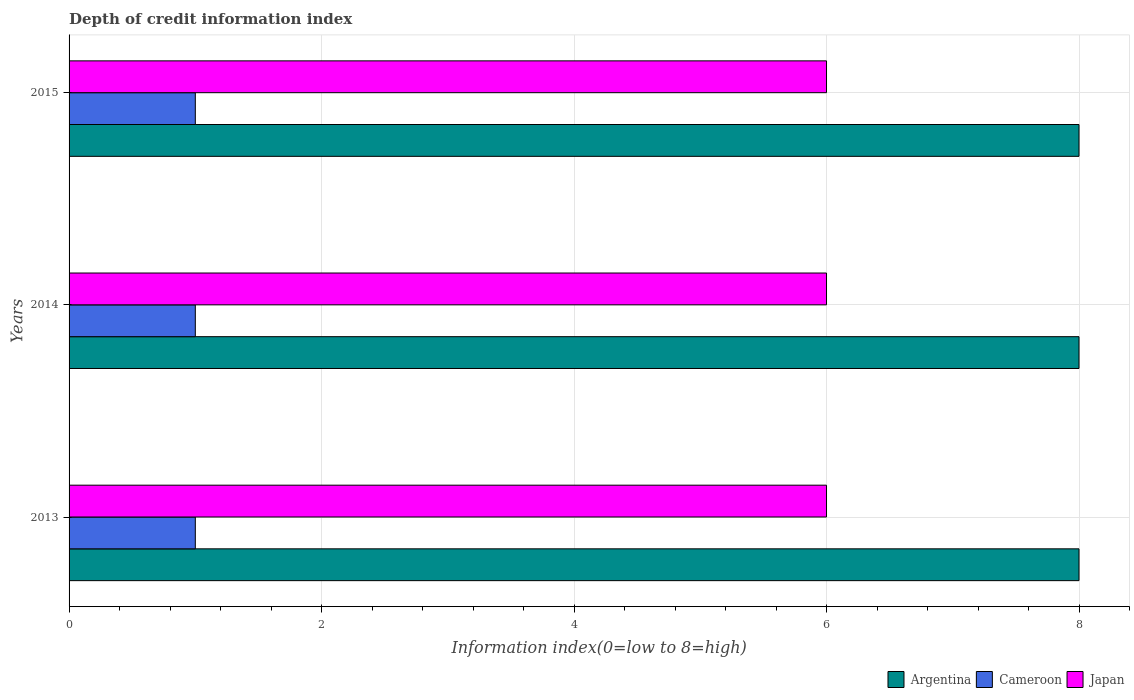How many groups of bars are there?
Offer a very short reply. 3. Are the number of bars per tick equal to the number of legend labels?
Ensure brevity in your answer.  Yes. Are the number of bars on each tick of the Y-axis equal?
Provide a succinct answer. Yes. How many bars are there on the 1st tick from the top?
Make the answer very short. 3. What is the label of the 1st group of bars from the top?
Offer a very short reply. 2015. In how many cases, is the number of bars for a given year not equal to the number of legend labels?
Your answer should be compact. 0. What is the information index in Argentina in 2015?
Your answer should be compact. 8. Across all years, what is the maximum information index in Cameroon?
Make the answer very short. 1. Across all years, what is the minimum information index in Argentina?
Keep it short and to the point. 8. In which year was the information index in Japan maximum?
Offer a terse response. 2013. In which year was the information index in Argentina minimum?
Give a very brief answer. 2013. What is the total information index in Argentina in the graph?
Ensure brevity in your answer.  24. What is the difference between the information index in Cameroon in 2014 and the information index in Argentina in 2015?
Offer a very short reply. -7. What is the average information index in Cameroon per year?
Keep it short and to the point. 1. In the year 2014, what is the difference between the information index in Cameroon and information index in Argentina?
Make the answer very short. -7. What is the ratio of the information index in Cameroon in 2013 to that in 2014?
Ensure brevity in your answer.  1. Is the information index in Japan in 2013 less than that in 2015?
Ensure brevity in your answer.  No. What is the difference between the highest and the second highest information index in Cameroon?
Keep it short and to the point. 0. What is the difference between the highest and the lowest information index in Argentina?
Offer a very short reply. 0. In how many years, is the information index in Argentina greater than the average information index in Argentina taken over all years?
Provide a short and direct response. 0. What does the 2nd bar from the top in 2013 represents?
Provide a succinct answer. Cameroon. What does the 3rd bar from the bottom in 2015 represents?
Your answer should be compact. Japan. Are all the bars in the graph horizontal?
Your answer should be compact. Yes. Where does the legend appear in the graph?
Offer a very short reply. Bottom right. How many legend labels are there?
Your answer should be very brief. 3. How are the legend labels stacked?
Provide a succinct answer. Horizontal. What is the title of the graph?
Your response must be concise. Depth of credit information index. Does "Hong Kong" appear as one of the legend labels in the graph?
Your response must be concise. No. What is the label or title of the X-axis?
Offer a very short reply. Information index(0=low to 8=high). What is the label or title of the Y-axis?
Ensure brevity in your answer.  Years. What is the Information index(0=low to 8=high) in Argentina in 2013?
Give a very brief answer. 8. What is the Information index(0=low to 8=high) in Japan in 2013?
Give a very brief answer. 6. What is the Information index(0=low to 8=high) of Argentina in 2015?
Offer a terse response. 8. What is the Information index(0=low to 8=high) of Cameroon in 2015?
Your response must be concise. 1. What is the Information index(0=low to 8=high) in Japan in 2015?
Your answer should be very brief. 6. Across all years, what is the maximum Information index(0=low to 8=high) of Argentina?
Provide a succinct answer. 8. Across all years, what is the minimum Information index(0=low to 8=high) in Japan?
Your answer should be compact. 6. What is the total Information index(0=low to 8=high) of Argentina in the graph?
Make the answer very short. 24. What is the total Information index(0=low to 8=high) in Cameroon in the graph?
Your answer should be very brief. 3. What is the total Information index(0=low to 8=high) of Japan in the graph?
Your response must be concise. 18. What is the difference between the Information index(0=low to 8=high) in Argentina in 2013 and that in 2014?
Offer a terse response. 0. What is the difference between the Information index(0=low to 8=high) of Japan in 2013 and that in 2015?
Provide a succinct answer. 0. What is the difference between the Information index(0=low to 8=high) in Argentina in 2014 and that in 2015?
Provide a short and direct response. 0. What is the difference between the Information index(0=low to 8=high) of Japan in 2014 and that in 2015?
Keep it short and to the point. 0. What is the difference between the Information index(0=low to 8=high) of Argentina in 2013 and the Information index(0=low to 8=high) of Cameroon in 2015?
Give a very brief answer. 7. What is the difference between the Information index(0=low to 8=high) in Cameroon in 2013 and the Information index(0=low to 8=high) in Japan in 2015?
Provide a short and direct response. -5. What is the difference between the Information index(0=low to 8=high) in Argentina in 2014 and the Information index(0=low to 8=high) in Japan in 2015?
Your answer should be compact. 2. What is the difference between the Information index(0=low to 8=high) in Cameroon in 2014 and the Information index(0=low to 8=high) in Japan in 2015?
Your answer should be very brief. -5. What is the average Information index(0=low to 8=high) in Argentina per year?
Offer a very short reply. 8. In the year 2013, what is the difference between the Information index(0=low to 8=high) of Argentina and Information index(0=low to 8=high) of Cameroon?
Make the answer very short. 7. In the year 2013, what is the difference between the Information index(0=low to 8=high) of Argentina and Information index(0=low to 8=high) of Japan?
Make the answer very short. 2. In the year 2014, what is the difference between the Information index(0=low to 8=high) in Argentina and Information index(0=low to 8=high) in Cameroon?
Your response must be concise. 7. In the year 2014, what is the difference between the Information index(0=low to 8=high) in Argentina and Information index(0=low to 8=high) in Japan?
Your answer should be compact. 2. In the year 2014, what is the difference between the Information index(0=low to 8=high) in Cameroon and Information index(0=low to 8=high) in Japan?
Your answer should be very brief. -5. In the year 2015, what is the difference between the Information index(0=low to 8=high) of Cameroon and Information index(0=low to 8=high) of Japan?
Keep it short and to the point. -5. What is the ratio of the Information index(0=low to 8=high) of Japan in 2013 to that in 2014?
Keep it short and to the point. 1. What is the ratio of the Information index(0=low to 8=high) in Argentina in 2013 to that in 2015?
Provide a short and direct response. 1. What is the ratio of the Information index(0=low to 8=high) of Cameroon in 2013 to that in 2015?
Provide a short and direct response. 1. What is the ratio of the Information index(0=low to 8=high) of Argentina in 2014 to that in 2015?
Ensure brevity in your answer.  1. What is the difference between the highest and the second highest Information index(0=low to 8=high) in Argentina?
Offer a very short reply. 0. What is the difference between the highest and the lowest Information index(0=low to 8=high) of Argentina?
Provide a succinct answer. 0. What is the difference between the highest and the lowest Information index(0=low to 8=high) in Cameroon?
Offer a very short reply. 0. 